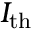Convert formula to latex. <formula><loc_0><loc_0><loc_500><loc_500>I _ { t h }</formula> 